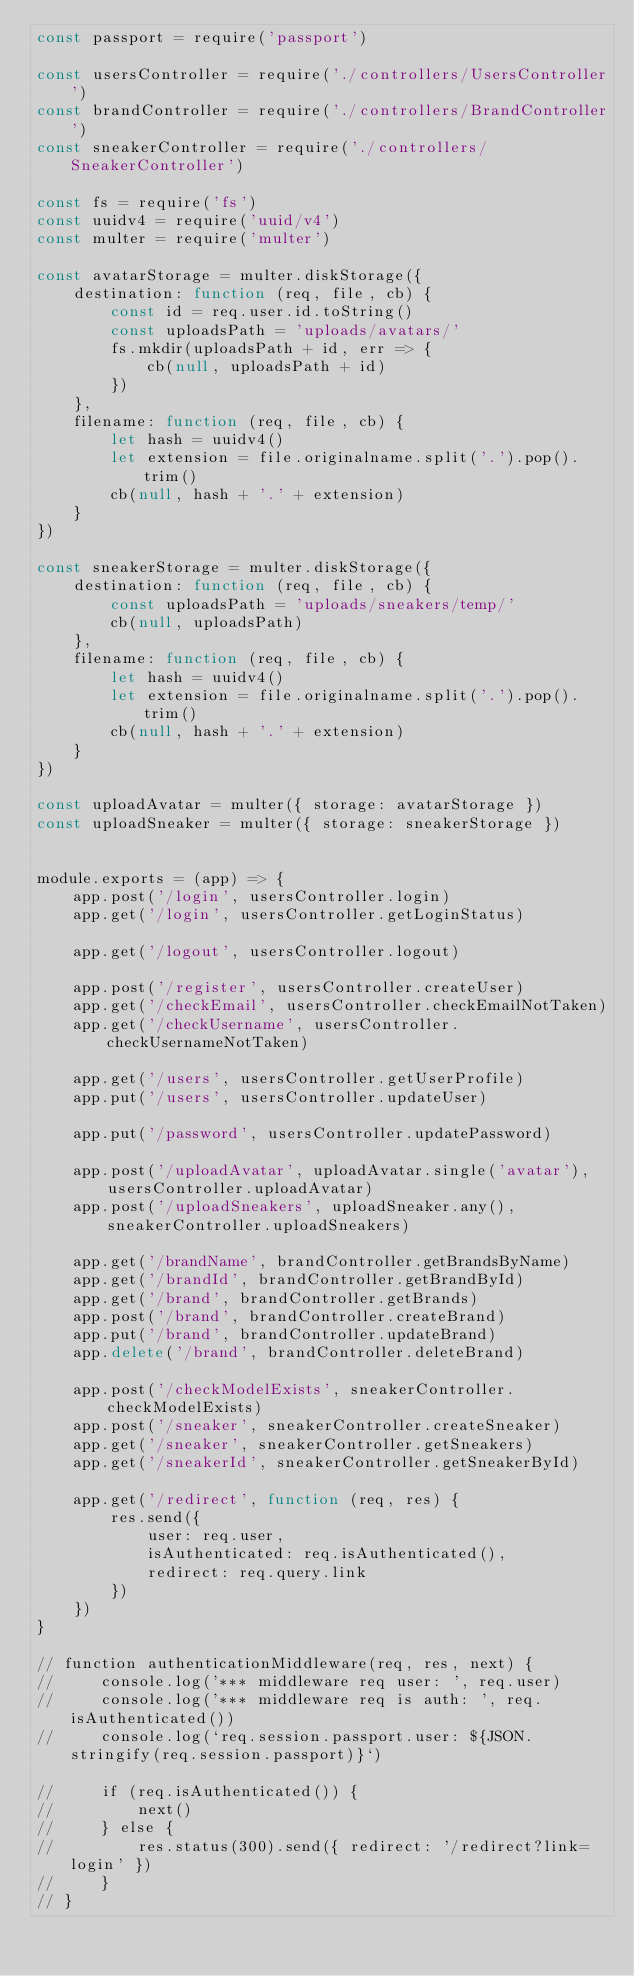<code> <loc_0><loc_0><loc_500><loc_500><_JavaScript_>const passport = require('passport')

const usersController = require('./controllers/UsersController')
const brandController = require('./controllers/BrandController')
const sneakerController = require('./controllers/SneakerController')

const fs = require('fs')
const uuidv4 = require('uuid/v4')
const multer = require('multer')

const avatarStorage = multer.diskStorage({
    destination: function (req, file, cb) {
        const id = req.user.id.toString()
        const uploadsPath = 'uploads/avatars/'
        fs.mkdir(uploadsPath + id, err => {
            cb(null, uploadsPath + id)
        })
    },
    filename: function (req, file, cb) {
        let hash = uuidv4()
        let extension = file.originalname.split('.').pop().trim()
        cb(null, hash + '.' + extension)
    }
})

const sneakerStorage = multer.diskStorage({
    destination: function (req, file, cb) {
        const uploadsPath = 'uploads/sneakers/temp/'
        cb(null, uploadsPath)
    },
    filename: function (req, file, cb) {
        let hash = uuidv4()
        let extension = file.originalname.split('.').pop().trim()
        cb(null, hash + '.' + extension)
    }
})

const uploadAvatar = multer({ storage: avatarStorage })
const uploadSneaker = multer({ storage: sneakerStorage })


module.exports = (app) => {
    app.post('/login', usersController.login)
    app.get('/login', usersController.getLoginStatus)

    app.get('/logout', usersController.logout)

    app.post('/register', usersController.createUser)
    app.get('/checkEmail', usersController.checkEmailNotTaken)
    app.get('/checkUsername', usersController.checkUsernameNotTaken)

    app.get('/users', usersController.getUserProfile)
    app.put('/users', usersController.updateUser)

    app.put('/password', usersController.updatePassword)

    app.post('/uploadAvatar', uploadAvatar.single('avatar'), usersController.uploadAvatar)
    app.post('/uploadSneakers', uploadSneaker.any(), sneakerController.uploadSneakers)

    app.get('/brandName', brandController.getBrandsByName)
    app.get('/brandId', brandController.getBrandById)
    app.get('/brand', brandController.getBrands)
    app.post('/brand', brandController.createBrand)
    app.put('/brand', brandController.updateBrand)
    app.delete('/brand', brandController.deleteBrand)

    app.post('/checkModelExists', sneakerController.checkModelExists)
    app.post('/sneaker', sneakerController.createSneaker)
    app.get('/sneaker', sneakerController.getSneakers)
    app.get('/sneakerId', sneakerController.getSneakerById)

    app.get('/redirect', function (req, res) {
        res.send({
            user: req.user,
            isAuthenticated: req.isAuthenticated(),
            redirect: req.query.link
        })
    })
}

// function authenticationMiddleware(req, res, next) {
//     console.log('*** middleware req user: ', req.user)
//     console.log('*** middleware req is auth: ', req.isAuthenticated())
//     console.log(`req.session.passport.user: ${JSON.stringify(req.session.passport)}`)

//     if (req.isAuthenticated()) {
//         next()
//     } else {
//         res.status(300).send({ redirect: '/redirect?link=login' })
//     }
// }
</code> 